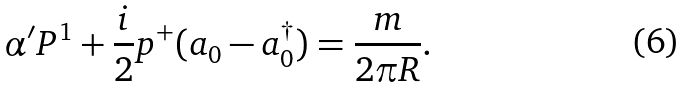Convert formula to latex. <formula><loc_0><loc_0><loc_500><loc_500>\alpha ^ { \prime } P ^ { 1 } + \frac { i } 2 p ^ { + } ( a _ { 0 } - a _ { 0 } ^ { \dagger } ) = \frac { m } { 2 \pi R } .</formula> 